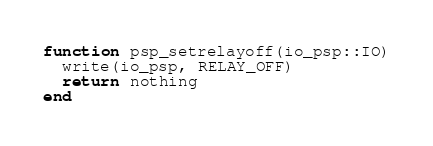<code> <loc_0><loc_0><loc_500><loc_500><_Julia_>function psp_setrelayoff(io_psp::IO)
  write(io_psp, RELAY_OFF)
  return nothing
end
</code> 